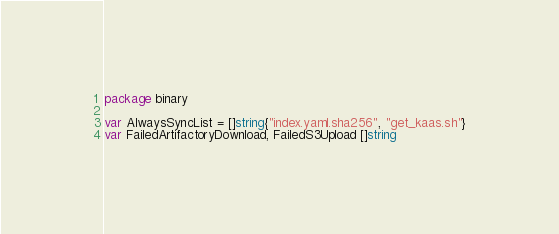Convert code to text. <code><loc_0><loc_0><loc_500><loc_500><_Go_>package binary

var AlwaysSyncList = []string{"index.yaml.sha256", "get_kaas.sh"}
var FailedArtifactoryDownload, FailedS3Upload []string
</code> 